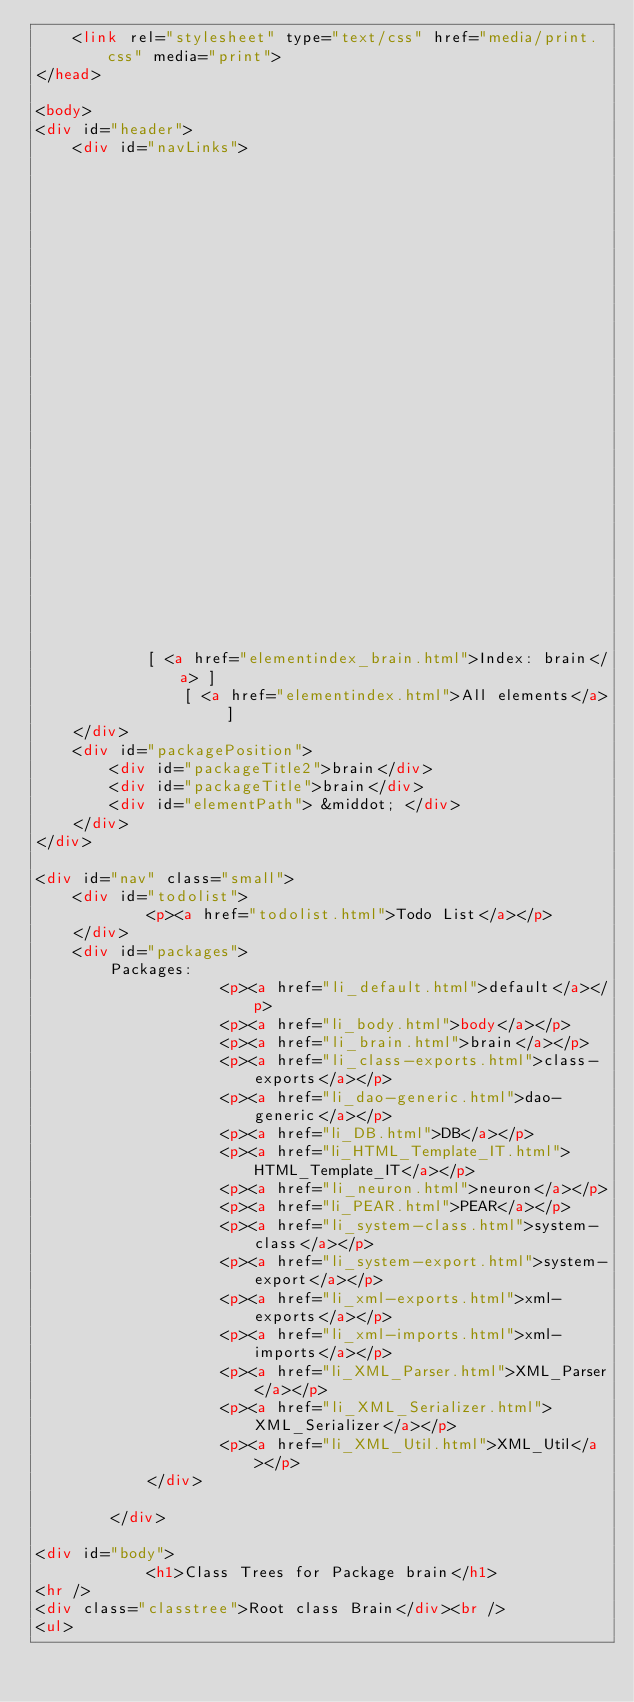Convert code to text. <code><loc_0><loc_0><loc_500><loc_500><_HTML_>	<link rel="stylesheet" type="text/css" href="media/print.css" media="print">
</head>

<body>
<div id="header">
	<div id="navLinks">
        
                                                                            
                                                                                                                                                                                                                                                                                                	        [ <a href="classtrees_brain.html">Class Tree: brain</a> ]
            [ <a href="elementindex_brain.html">Index: brain</a> ]
        		[ <a href="elementindex.html">All elements</a> ]		
	</div>
	<div id="packagePosition">
		<div id="packageTitle2">brain</div>
		<div id="packageTitle">brain</div>
		<div id="elementPath"> &middot; </div>
	</div>
</div>

<div id="nav" class="small">
	<div id="todolist">
			<p><a href="todolist.html">Todo List</a></p>
	</div>
	<div id="packages">
		Packages:
					<p><a href="li_default.html">default</a></p>
					<p><a href="li_body.html">body</a></p>
					<p><a href="li_brain.html">brain</a></p>
					<p><a href="li_class-exports.html">class-exports</a></p>
					<p><a href="li_dao-generic.html">dao-generic</a></p>
					<p><a href="li_DB.html">DB</a></p>
					<p><a href="li_HTML_Template_IT.html">HTML_Template_IT</a></p>
					<p><a href="li_neuron.html">neuron</a></p>
					<p><a href="li_PEAR.html">PEAR</a></p>
					<p><a href="li_system-class.html">system-class</a></p>
					<p><a href="li_system-export.html">system-export</a></p>
					<p><a href="li_xml-exports.html">xml-exports</a></p>
					<p><a href="li_xml-imports.html">xml-imports</a></p>
					<p><a href="li_XML_Parser.html">XML_Parser</a></p>
					<p><a href="li_XML_Serializer.html">XML_Serializer</a></p>
					<p><a href="li_XML_Util.html">XML_Util</a></p>
			</div>

		</div>

<div id="body">
	    	<h1>Class Trees for Package brain</h1>
<hr />
<div class="classtree">Root class Brain</div><br />
<ul></code> 